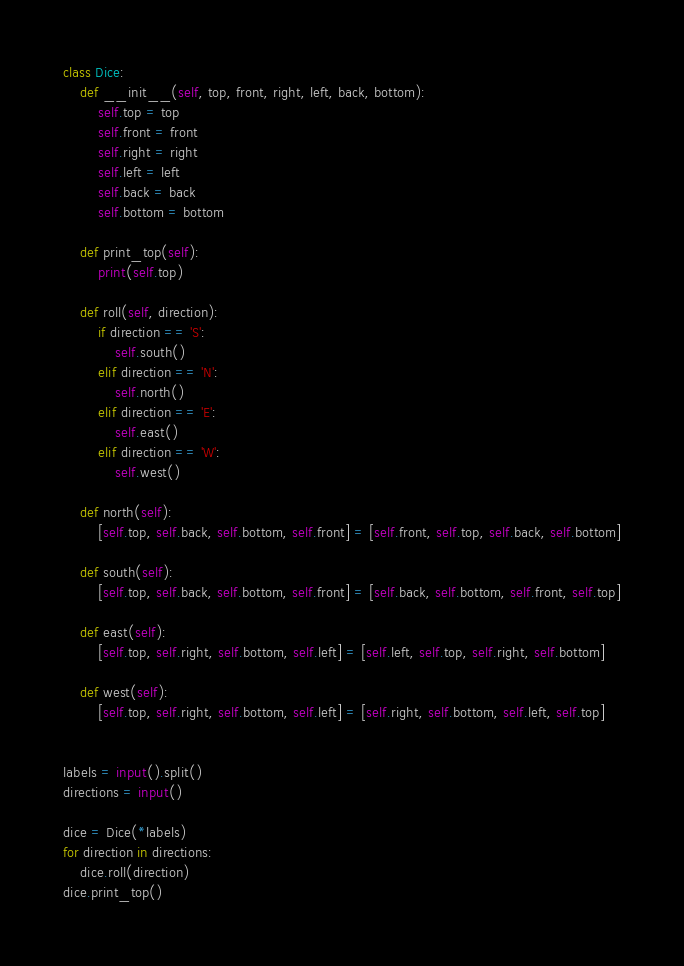<code> <loc_0><loc_0><loc_500><loc_500><_Python_>class Dice:
    def __init__(self, top, front, right, left, back, bottom):
        self.top = top
        self.front = front
        self.right = right
        self.left = left
        self.back = back
        self.bottom = bottom

    def print_top(self):
        print(self.top)

    def roll(self, direction):
        if direction == 'S':
            self.south()
        elif direction == 'N':
            self.north()
        elif direction == 'E':
            self.east()
        elif direction == 'W':
            self.west()

    def north(self):
        [self.top, self.back, self.bottom, self.front] = [self.front, self.top, self.back, self.bottom]

    def south(self):
        [self.top, self.back, self.bottom, self.front] = [self.back, self.bottom, self.front, self.top]

    def east(self):
        [self.top, self.right, self.bottom, self.left] = [self.left, self.top, self.right, self.bottom]

    def west(self):
        [self.top, self.right, self.bottom, self.left] = [self.right, self.bottom, self.left, self.top]


labels = input().split()
directions = input()

dice = Dice(*labels)
for direction in directions:
    dice.roll(direction)
dice.print_top()

</code> 